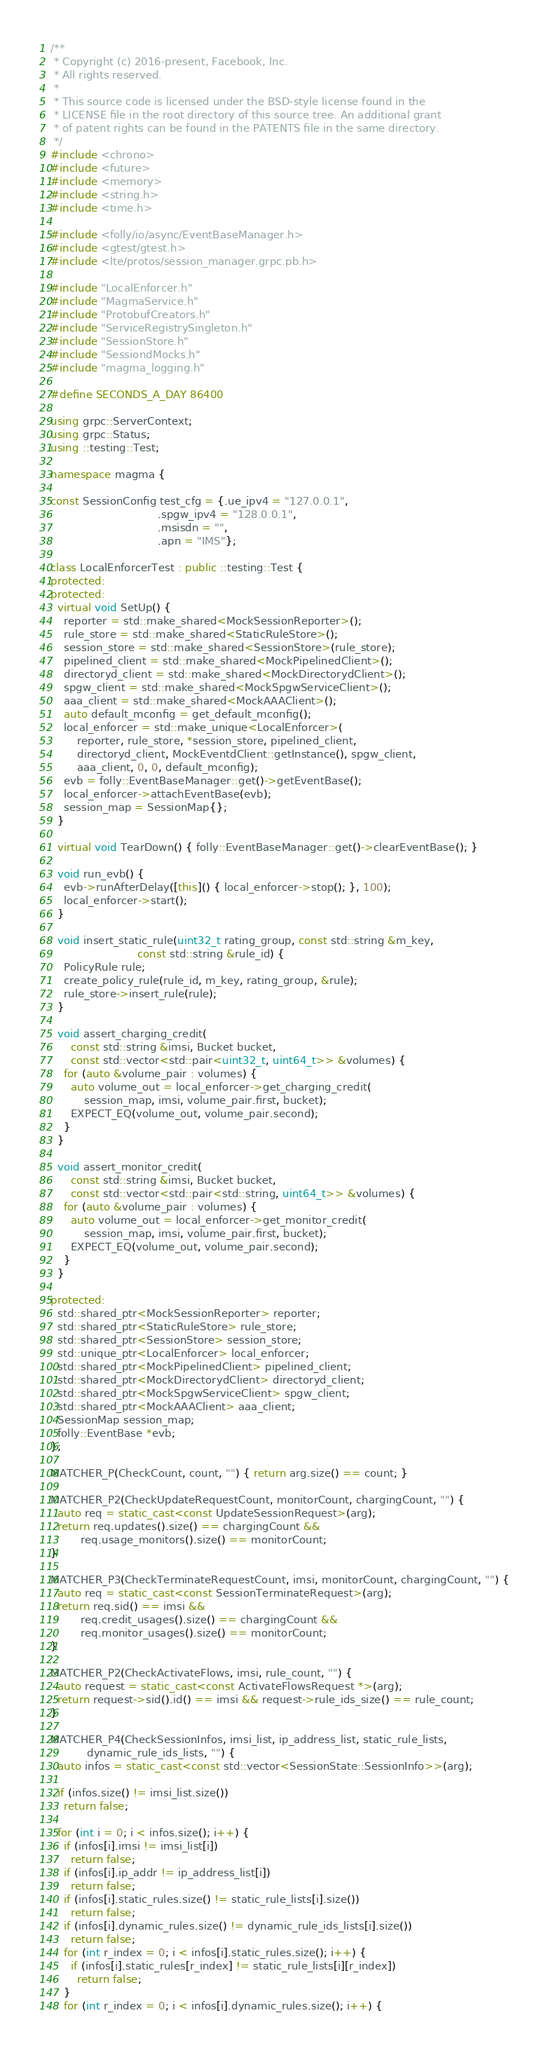Convert code to text. <code><loc_0><loc_0><loc_500><loc_500><_C++_>/**
 * Copyright (c) 2016-present, Facebook, Inc.
 * All rights reserved.
 *
 * This source code is licensed under the BSD-style license found in the
 * LICENSE file in the root directory of this source tree. An additional grant
 * of patent rights can be found in the PATENTS file in the same directory.
 */
#include <chrono>
#include <future>
#include <memory>
#include <string.h>
#include <time.h>

#include <folly/io/async/EventBaseManager.h>
#include <gtest/gtest.h>
#include <lte/protos/session_manager.grpc.pb.h>

#include "LocalEnforcer.h"
#include "MagmaService.h"
#include "ProtobufCreators.h"
#include "ServiceRegistrySingleton.h"
#include "SessionStore.h"
#include "SessiondMocks.h"
#include "magma_logging.h"

#define SECONDS_A_DAY 86400

using grpc::ServerContext;
using grpc::Status;
using ::testing::Test;

namespace magma {

const SessionConfig test_cfg = {.ue_ipv4 = "127.0.0.1",
                                .spgw_ipv4 = "128.0.0.1",
                                .msisdn = "",
                                .apn = "IMS"};

class LocalEnforcerTest : public ::testing::Test {
protected:
protected:
  virtual void SetUp() {
    reporter = std::make_shared<MockSessionReporter>();
    rule_store = std::make_shared<StaticRuleStore>();
    session_store = std::make_shared<SessionStore>(rule_store);
    pipelined_client = std::make_shared<MockPipelinedClient>();
    directoryd_client = std::make_shared<MockDirectorydClient>();
    spgw_client = std::make_shared<MockSpgwServiceClient>();
    aaa_client = std::make_shared<MockAAAClient>();
    auto default_mconfig = get_default_mconfig();
    local_enforcer = std::make_unique<LocalEnforcer>(
        reporter, rule_store, *session_store, pipelined_client,
        directoryd_client, MockEventdClient::getInstance(), spgw_client,
        aaa_client, 0, 0, default_mconfig);
    evb = folly::EventBaseManager::get()->getEventBase();
    local_enforcer->attachEventBase(evb);
    session_map = SessionMap{};
  }

  virtual void TearDown() { folly::EventBaseManager::get()->clearEventBase(); }

  void run_evb() {
    evb->runAfterDelay([this]() { local_enforcer->stop(); }, 100);
    local_enforcer->start();
  }

  void insert_static_rule(uint32_t rating_group, const std::string &m_key,
                          const std::string &rule_id) {
    PolicyRule rule;
    create_policy_rule(rule_id, m_key, rating_group, &rule);
    rule_store->insert_rule(rule);
  }

  void assert_charging_credit(
      const std::string &imsi, Bucket bucket,
      const std::vector<std::pair<uint32_t, uint64_t>> &volumes) {
    for (auto &volume_pair : volumes) {
      auto volume_out = local_enforcer->get_charging_credit(
          session_map, imsi, volume_pair.first, bucket);
      EXPECT_EQ(volume_out, volume_pair.second);
    }
  }

  void assert_monitor_credit(
      const std::string &imsi, Bucket bucket,
      const std::vector<std::pair<std::string, uint64_t>> &volumes) {
    for (auto &volume_pair : volumes) {
      auto volume_out = local_enforcer->get_monitor_credit(
          session_map, imsi, volume_pair.first, bucket);
      EXPECT_EQ(volume_out, volume_pair.second);
    }
  }

protected:
  std::shared_ptr<MockSessionReporter> reporter;
  std::shared_ptr<StaticRuleStore> rule_store;
  std::shared_ptr<SessionStore> session_store;
  std::unique_ptr<LocalEnforcer> local_enforcer;
  std::shared_ptr<MockPipelinedClient> pipelined_client;
  std::shared_ptr<MockDirectorydClient> directoryd_client;
  std::shared_ptr<MockSpgwServiceClient> spgw_client;
  std::shared_ptr<MockAAAClient> aaa_client;
  SessionMap session_map;
  folly::EventBase *evb;
};

MATCHER_P(CheckCount, count, "") { return arg.size() == count; }

MATCHER_P2(CheckUpdateRequestCount, monitorCount, chargingCount, "") {
  auto req = static_cast<const UpdateSessionRequest>(arg);
  return req.updates().size() == chargingCount &&
         req.usage_monitors().size() == monitorCount;
}

MATCHER_P3(CheckTerminateRequestCount, imsi, monitorCount, chargingCount, "") {
  auto req = static_cast<const SessionTerminateRequest>(arg);
  return req.sid() == imsi &&
         req.credit_usages().size() == chargingCount &&
         req.monitor_usages().size() == monitorCount;
}

MATCHER_P2(CheckActivateFlows, imsi, rule_count, "") {
  auto request = static_cast<const ActivateFlowsRequest *>(arg);
  return request->sid().id() == imsi && request->rule_ids_size() == rule_count;
}

MATCHER_P4(CheckSessionInfos, imsi_list, ip_address_list, static_rule_lists,
           dynamic_rule_ids_lists, "") {
  auto infos = static_cast<const std::vector<SessionState::SessionInfo>>(arg);

  if (infos.size() != imsi_list.size())
    return false;

  for (int i = 0; i < infos.size(); i++) {
    if (infos[i].imsi != imsi_list[i])
      return false;
    if (infos[i].ip_addr != ip_address_list[i])
      return false;
    if (infos[i].static_rules.size() != static_rule_lists[i].size())
      return false;
    if (infos[i].dynamic_rules.size() != dynamic_rule_ids_lists[i].size())
      return false;
    for (int r_index = 0; i < infos[i].static_rules.size(); i++) {
      if (infos[i].static_rules[r_index] != static_rule_lists[i][r_index])
        return false;
    }
    for (int r_index = 0; i < infos[i].dynamic_rules.size(); i++) {</code> 